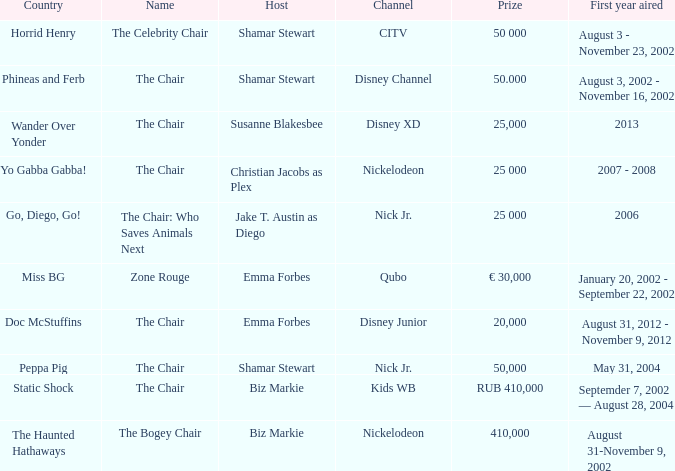Who was the emcee of horrid henry? Shamar Stewart. 